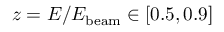Convert formula to latex. <formula><loc_0><loc_0><loc_500><loc_500>z = E / E _ { b e a m } \in [ 0 . 5 , 0 . 9 ]</formula> 